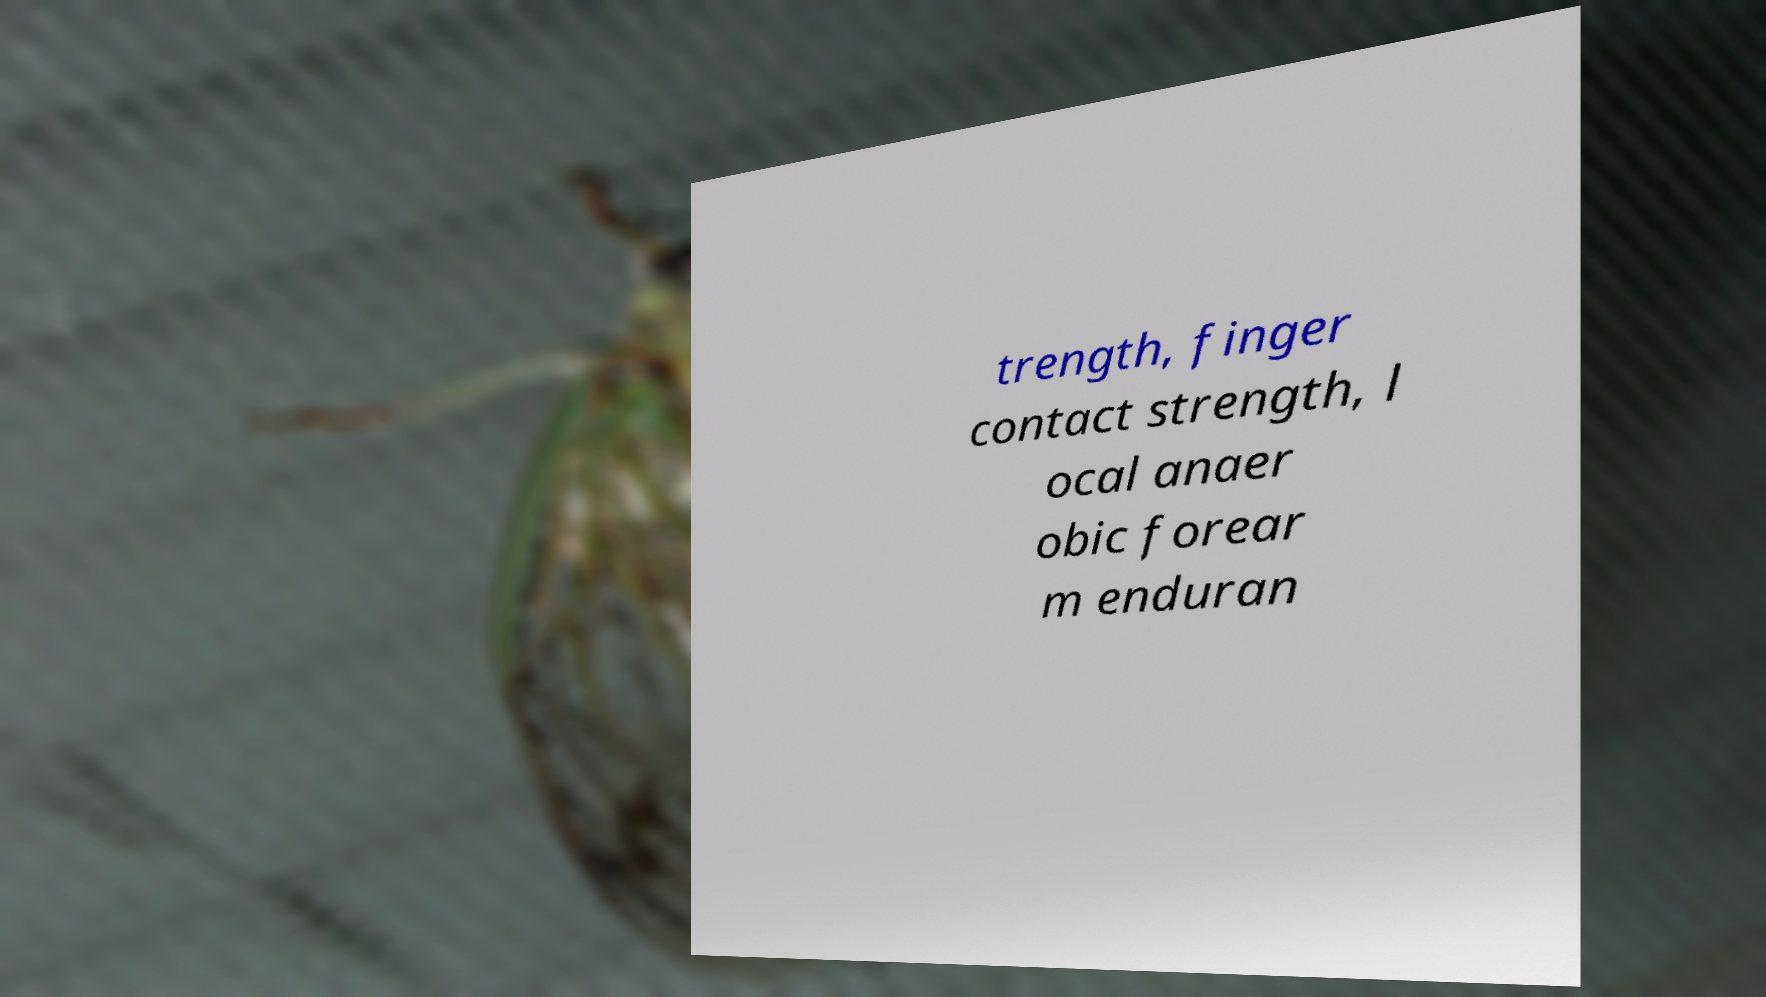For documentation purposes, I need the text within this image transcribed. Could you provide that? trength, finger contact strength, l ocal anaer obic forear m enduran 